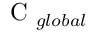<formula> <loc_0><loc_0><loc_500><loc_500>C _ { g l o b a l }</formula> 